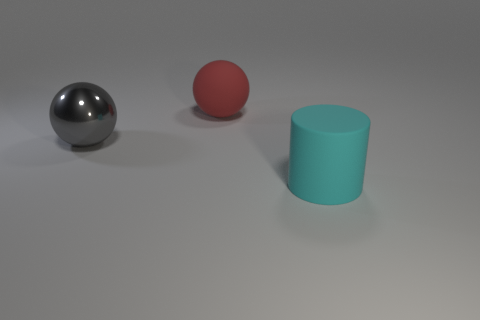Add 3 big cyan cylinders. How many objects exist? 6 Subtract all spheres. How many objects are left? 1 Add 2 small gray things. How many small gray things exist? 2 Subtract 0 yellow blocks. How many objects are left? 3 Subtract all big cyan shiny spheres. Subtract all big objects. How many objects are left? 0 Add 2 red balls. How many red balls are left? 3 